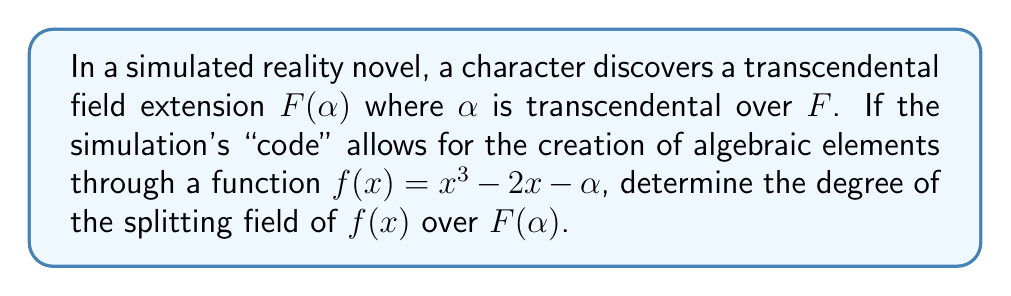Give your solution to this math problem. 1) First, we need to understand that $α$ is transcendental over $F$, meaning $F(α)$ is a transcendental extension of $F$.

2) The polynomial $f(x) = x^3 - 2x - α$ is defined over $F(α)$.

3) Let's consider the splitting field of $f(x)$ over $F(α)$. To do this, we need to find the roots of $f(x)$.

4) The discriminant of $f(x)$ is:
   $$Δ = -4(-2)^3 - 27(-α)^2 = -4(-8) - 27α^2 = 32 - 27α^2$$

5) Since $α$ is transcendental, $Δ ≠ 0$, so $f(x)$ has three distinct roots.

6) Let $β$ be one of the roots of $f(x)$. Then $β$ is algebraic over $F(α)$ of degree 3.

7) The splitting field of $f(x)$ over $F(α)$ is $F(α, β)$.

8) Since $[F(α, β) : F(α)] = 3$ and $F(α, β)$ contains all roots of $f(x)$, this is the degree of the splitting field.
Answer: 3 